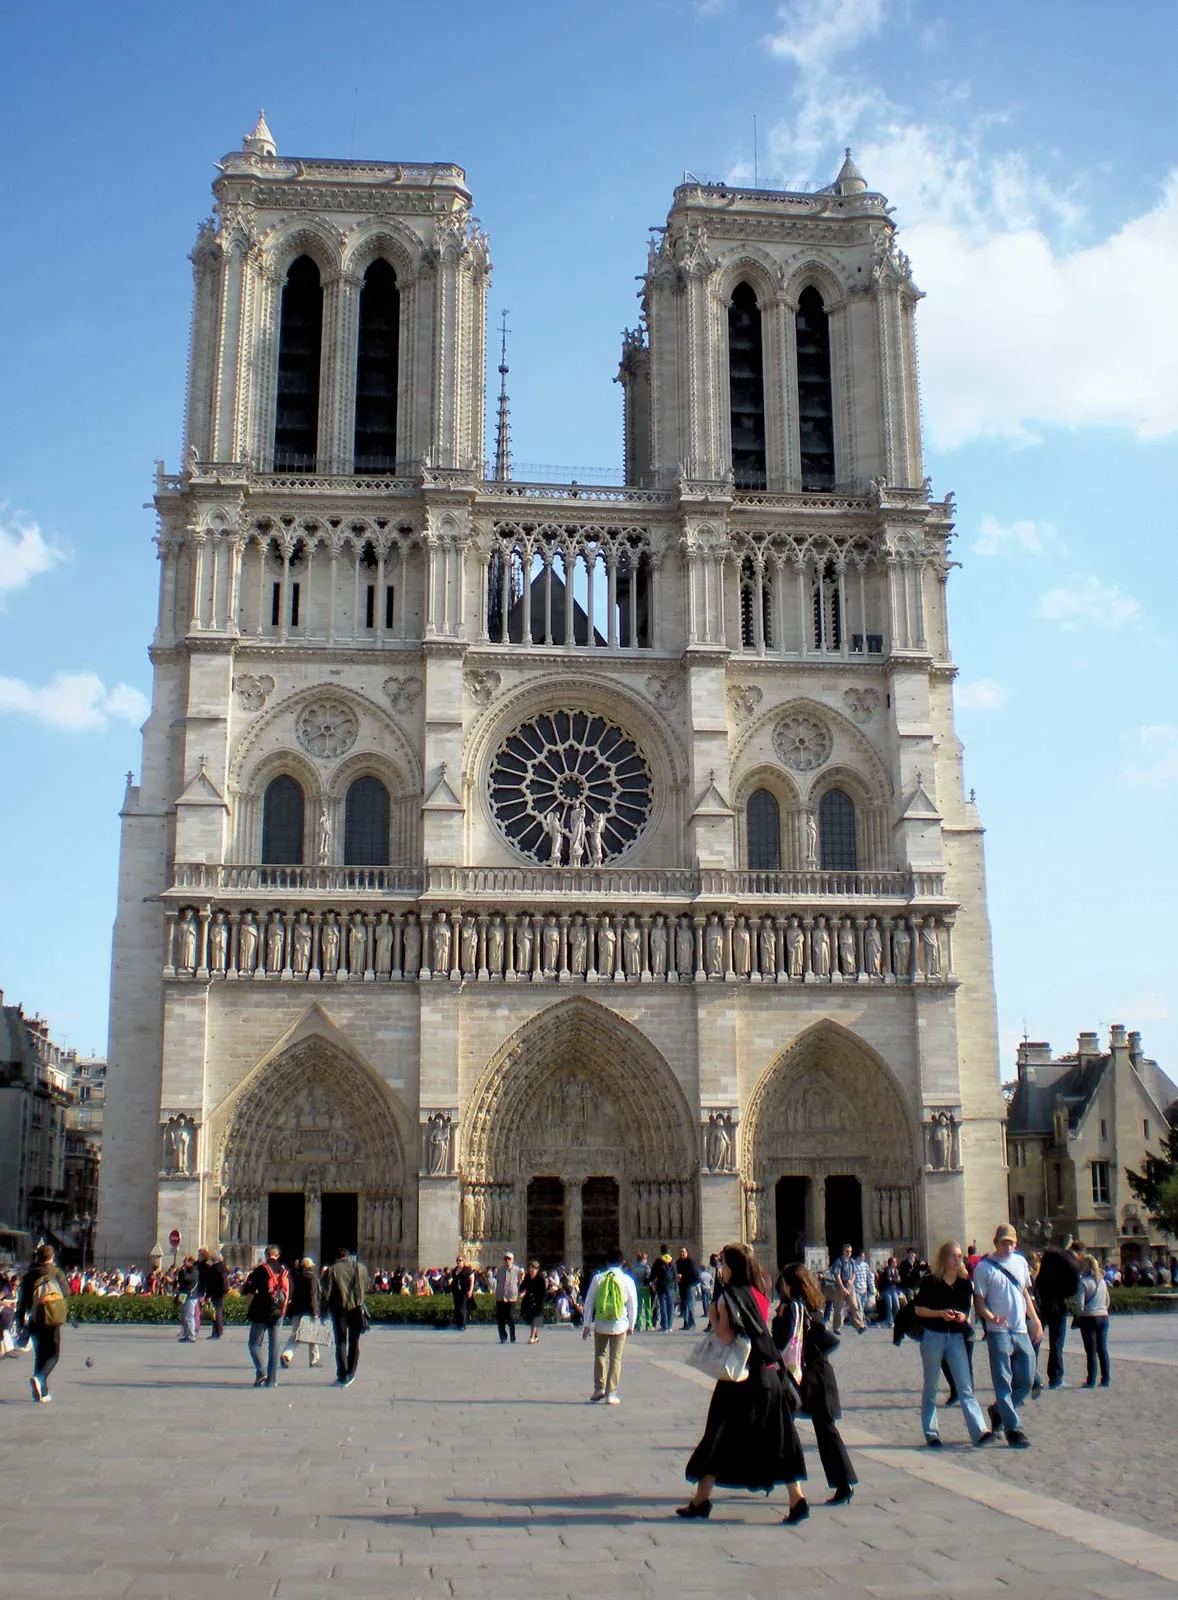What historical events took place at this location? Notre Dame Cathedral has been the site of numerous significant historical events. One notable event was the coronation of Napoleon Bonaparte as Emperor of France in 1804. Additionally, the cathedral has witnessed many royal weddings and funerals. During World War II, it narrowly avoided destruction, preserving its historic architecture and artifacts. In modern times, the devastating fire in April 2019, which caused significant damage, was a major event that brought global attention to the cathedral's cultural and historical value. 